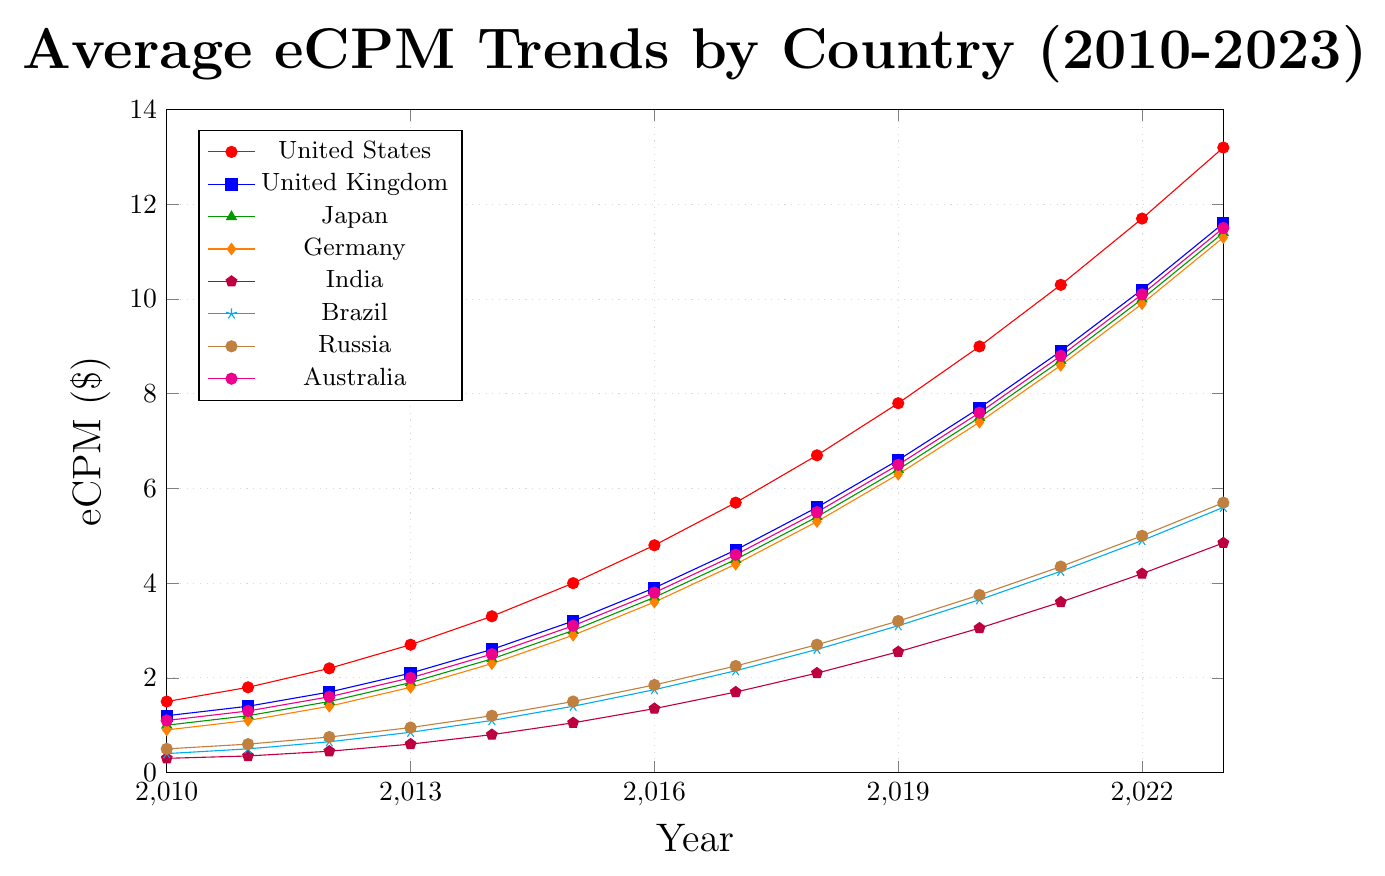What is the trend of eCPM in the United States from 2010 to 2023? The eCPM in the United States has shown a steady increase from 1.50 in 2010 to 13.20 in 2023, indicating continuous growth in ad revenue over this period.
Answer: Increasing Which country had the highest eCPM in 2023? In 2023, the United States had the highest eCPM at 13.20, as indicated by the topmost line in the graph.
Answer: United States What is the percentage increase in eCPM for India from 2010 to 2023? The eCPM for India increased from 0.30 in 2010 to 4.85 in 2023. The percentage increase can be calculated as ((4.85 - 0.30) / 0.30) * 100%. This equals (4.55 / 0.30) * 100% ≈ 1516.67%.
Answer: Approximately 1516.67% Between Japan and Germany, which country had a higher eCPM in 2015, and by how much? In 2015, Japan had an eCPM of 3.00, while Germany had an eCPM of 2.90. Japan's eCPM was higher by 3.00 - 2.90 = 0.10.
Answer: Japan by 0.10 What is the overall trend of eCPM for Brazil from 2010 to 2023? The eCPM for Brazil has shown a consistent upward trend, starting from 0.40 in 2010 to 5.60 in 2023, indicating that the ad revenue has been increasing over this period.
Answer: Increasing Compare the eCPM growth between 2010 and 2023 for United Kingdom and Australia and identify which one had greater absolute growth. For the United Kingdom, the eCPM grew from 1.20 in 2010 to 11.60 in 2023, an absolute growth of 11.60 - 1.20 = 10.40. 
For Australia, the eCPM grew from 1.10 in 2010 to 11.50 in 2023, an absolute growth of 11.50 - 1.10 = 10.40. 
Both countries had the same absolute eCPM growth of 10.40.
Answer: Equal In what year did Russia's eCPM first exceed 3.00? The eCPM for Russia first exceeded 3.00 in 2019, where it reached 3.20.
Answer: 2019 Which country had the lowest eCPM in 2023, and what was the value? In 2023, India had the lowest eCPM, which was 4.85, as indicated by the bottommost line in the graph.
Answer: India, 4.85 What was the difference in eCPM between Brazil and Russia in 2021? In 2021, Brazil's eCPM was 4.25, and Russia's eCPM was 4.35. The difference is 4.35 - 4.25 = 0.10.
Answer: 0.10 